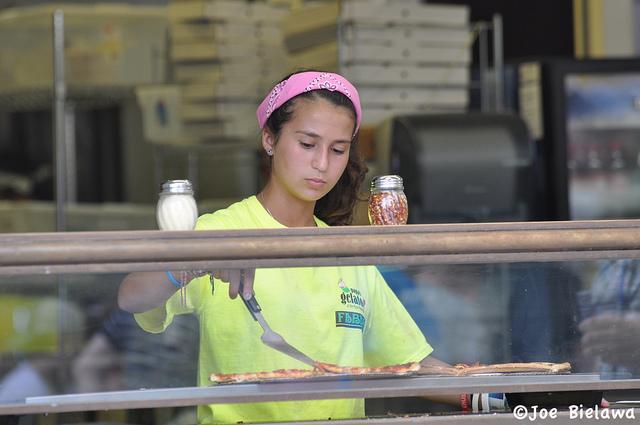What is in the glass jar on the right?
Keep it brief. Red pepper. What is this person scooping up?
Give a very brief answer. Pizza. What color is the girl's shirt?
Answer briefly. Yellow. 